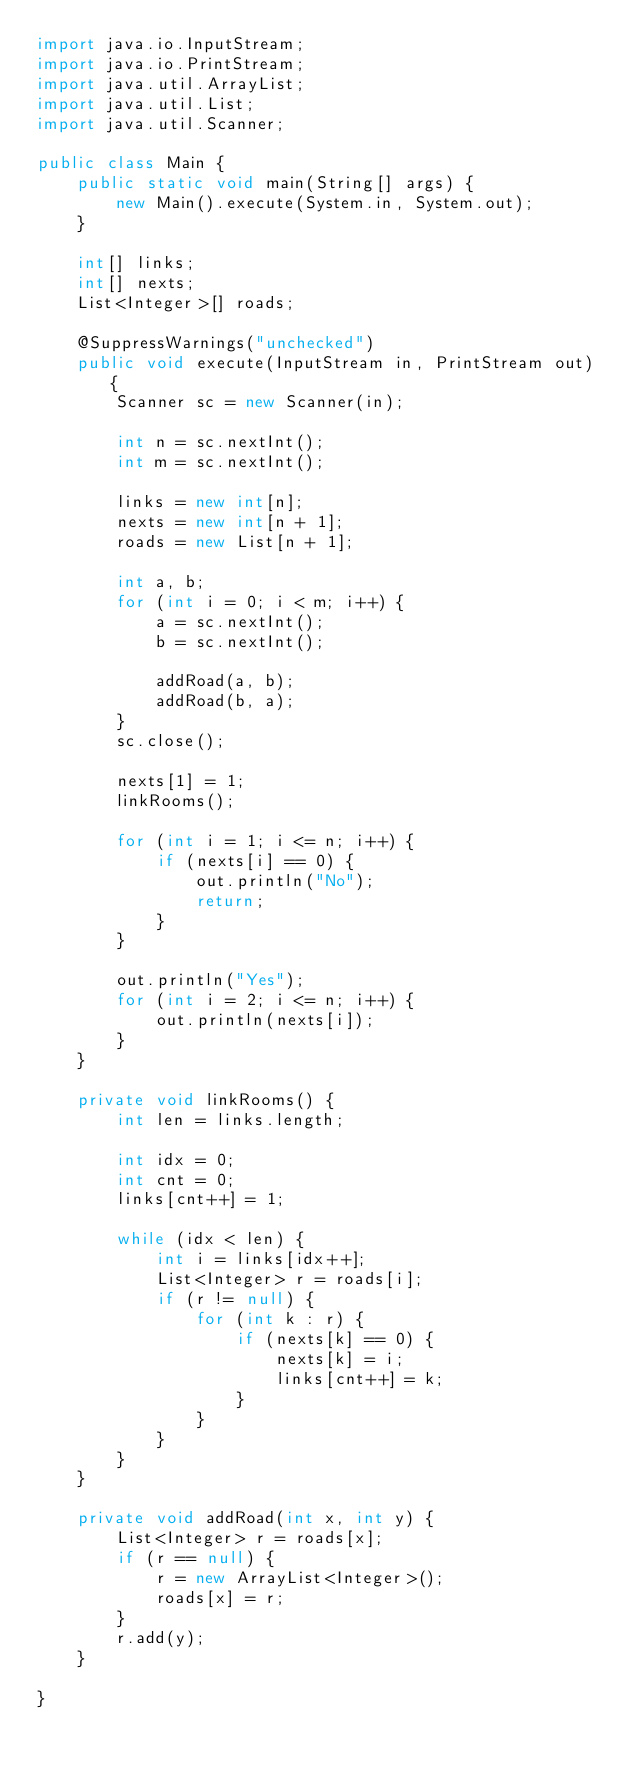<code> <loc_0><loc_0><loc_500><loc_500><_Java_>import java.io.InputStream;
import java.io.PrintStream;
import java.util.ArrayList;
import java.util.List;
import java.util.Scanner;

public class Main {
	public static void main(String[] args) {
		new Main().execute(System.in, System.out);
	}

	int[] links;
	int[] nexts;
	List<Integer>[] roads;

	@SuppressWarnings("unchecked")
	public void execute(InputStream in, PrintStream out) {
		Scanner sc = new Scanner(in);

		int n = sc.nextInt();
		int m = sc.nextInt();

		links = new int[n];
		nexts = new int[n + 1];
		roads = new List[n + 1];

		int a, b;
		for (int i = 0; i < m; i++) {
			a = sc.nextInt();
			b = sc.nextInt();
			
			addRoad(a, b);
			addRoad(b, a);
		}
		sc.close();
		
		nexts[1] = 1;
		linkRooms();

		for (int i = 1; i <= n; i++) {
			if (nexts[i] == 0) {
				out.println("No");
				return;
			}
		}
		
		out.println("Yes");
		for (int i = 2; i <= n; i++) {
			out.println(nexts[i]);
		}
	}

	private void linkRooms() {
		int len = links.length;

		int idx = 0;
		int cnt = 0;
		links[cnt++] = 1;

		while (idx < len) {
			int i = links[idx++];
			List<Integer> r = roads[i];
			if (r != null) {
				for (int k : r) {
					if (nexts[k] == 0) {
						nexts[k] = i;
						links[cnt++] = k;
					}
				}
			}
		}
	}

	private void addRoad(int x, int y) {
		List<Integer> r = roads[x];
		if (r == null) {
			r = new ArrayList<Integer>();
			roads[x] = r;
		}
		r.add(y);
	}

}
</code> 